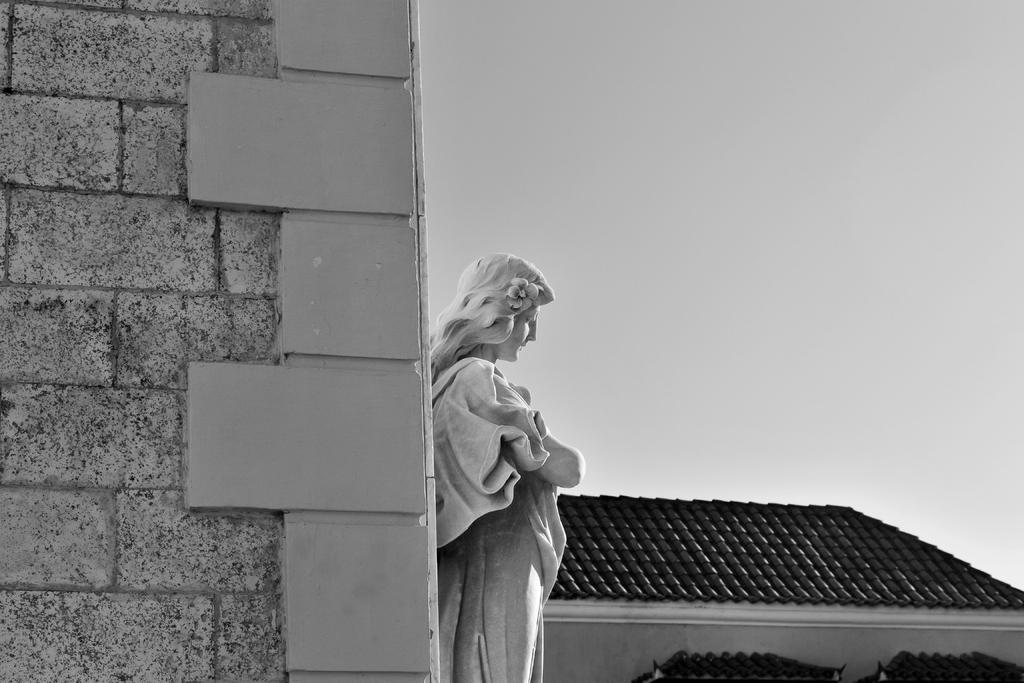What is the main subject in the middle of the image? There is a statue in the middle of the image. What is located beside the statue? There is a wall beside the statue. What can be seen in the background of the image? There is a building with a roof and the sky visible in the background of the image. How does the donkey feel about the statue in the image? There is no donkey present in the image, so it is not possible to determine how a donkey might feel about the statue. 